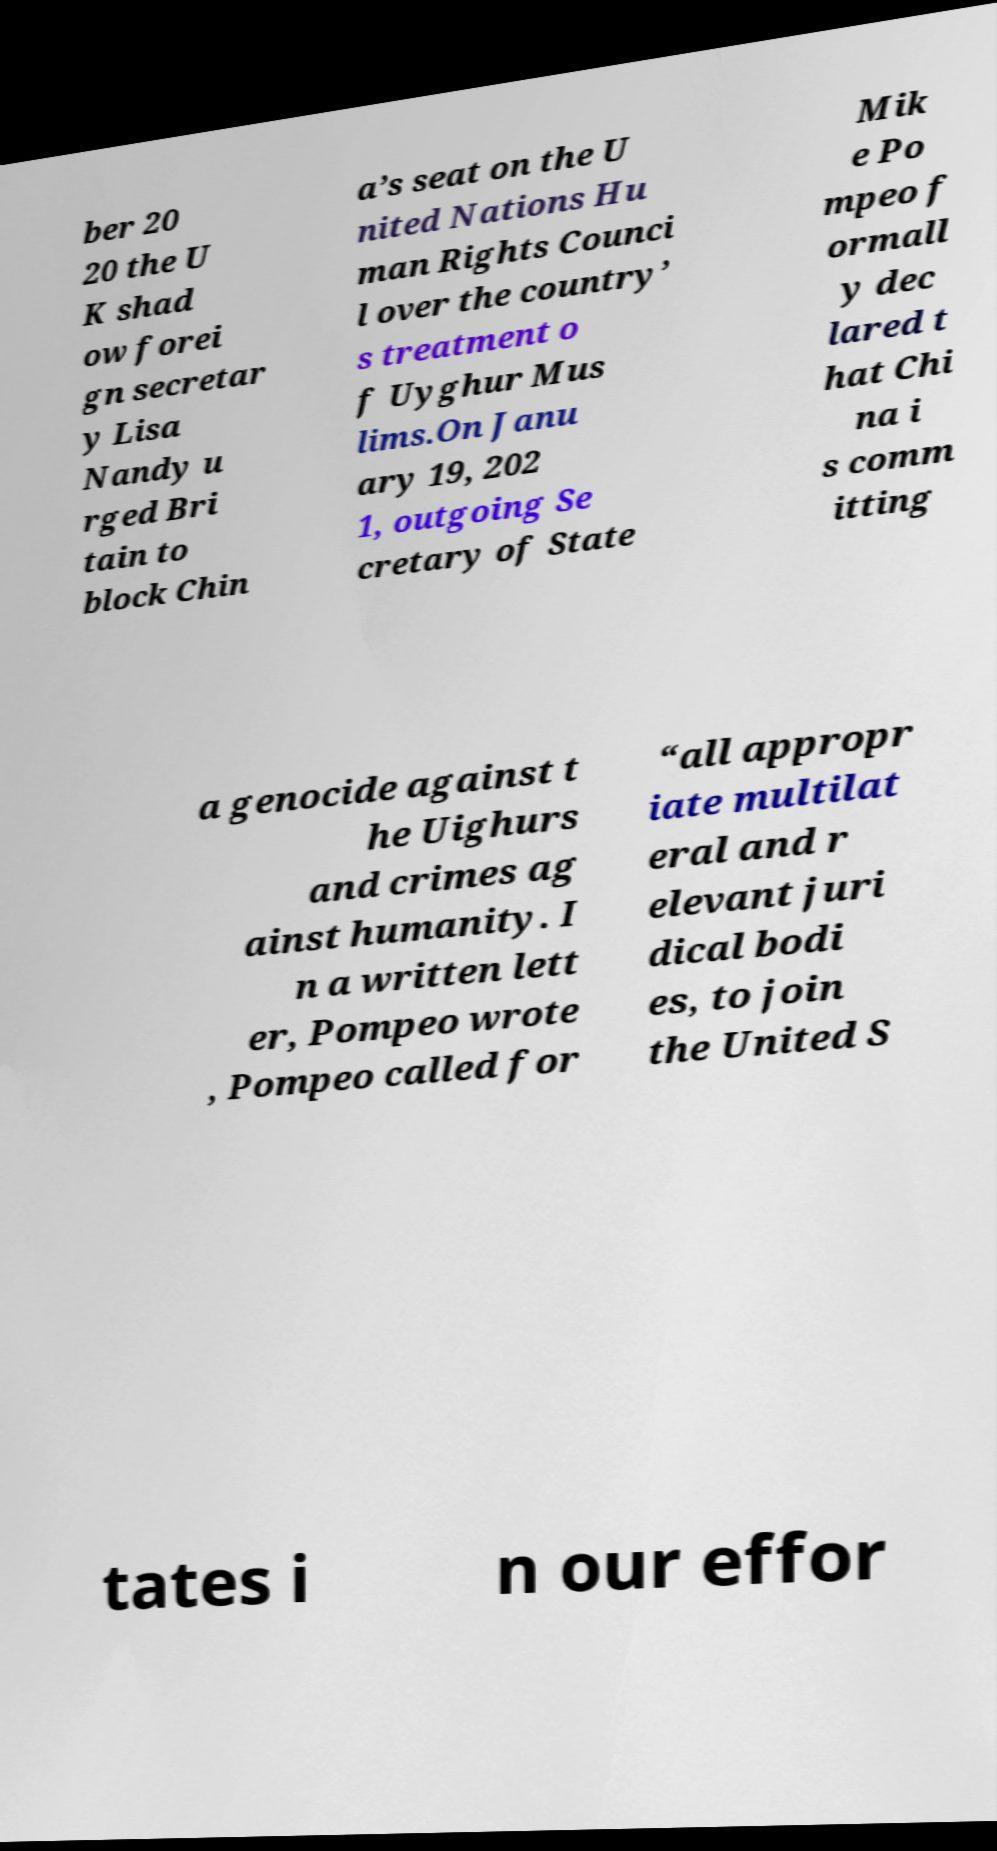Could you assist in decoding the text presented in this image and type it out clearly? ber 20 20 the U K shad ow forei gn secretar y Lisa Nandy u rged Bri tain to block Chin a’s seat on the U nited Nations Hu man Rights Counci l over the country’ s treatment o f Uyghur Mus lims.On Janu ary 19, 202 1, outgoing Se cretary of State Mik e Po mpeo f ormall y dec lared t hat Chi na i s comm itting a genocide against t he Uighurs and crimes ag ainst humanity. I n a written lett er, Pompeo wrote , Pompeo called for “all appropr iate multilat eral and r elevant juri dical bodi es, to join the United S tates i n our effor 